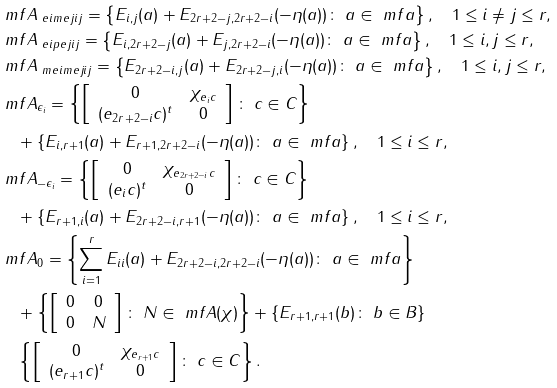Convert formula to latex. <formula><loc_0><loc_0><loc_500><loc_500>& \ m f A _ { \ e i m e j { i } { j } } = \left \{ E _ { i , j } ( a ) + E _ { 2 r + 2 - j , 2 r + 2 - i } ( - \eta ( a ) ) \colon \ a \in \ m f a \right \} , \quad 1 \leq i \neq j \leq r , \\ & \ m f A _ { \ e i p e j { i } { j } } = \left \{ E _ { i , 2 r + 2 - j } ( a ) + E _ { j , 2 r + 2 - i } ( - \eta ( a ) ) \colon \ a \in \ m f a \right \} , \quad 1 \leq i , j \leq r , \\ & \ m f A _ { \ m e i m e j { i } { j } } = \left \{ E _ { 2 r + 2 - i , j } ( a ) + E _ { 2 r + 2 - j , i } ( - \eta ( a ) ) \colon \ a \in \ m f a \right \} , \quad 1 \leq i , j \leq r , \\ & \ m f A _ { \epsilon _ { i } } = \left \{ \left [ \begin{array} { c c } 0 & \chi _ { e _ { i } c } \\ ( e _ { 2 r + 2 - i } c ) ^ { t } & 0 \end{array} \right ] \colon \ c \in C \right \} \\ & \quad + \left \{ E _ { i , r + 1 } ( a ) + E _ { r + 1 , 2 r + 2 - i } ( - \eta ( a ) ) \colon \ a \in \ m f a \right \} , \quad 1 \leq i \leq r , \\ & \ m f A _ { - \epsilon _ { i } } = \left \{ \left [ \begin{array} { c c } 0 & \chi _ { e _ { 2 r + 2 - i } c } \\ ( e _ { i } c ) ^ { t } & 0 \end{array} \right ] \colon \ c \in C \right \} \\ & \quad + \left \{ E _ { r + 1 , i } ( a ) + E _ { 2 r + 2 - i , r + 1 } ( - \eta ( a ) ) \colon \ a \in \ m f a \right \} , \quad 1 \leq i \leq r , \\ & \ m f A _ { 0 } = \left \{ \sum _ { i = 1 } ^ { r } E _ { i i } ( a ) + E _ { 2 r + 2 - i , 2 r + 2 - i } ( - \eta ( a ) ) \colon \ a \in \ m f a \right \} \\ & \quad + \left \{ \left [ \begin{array} { c c } 0 & 0 \\ 0 & N \end{array} \right ] \colon \ N \in \ m f A ( \chi ) \right \} + \left \{ E _ { r + 1 , r + 1 } ( b ) \colon \ b \in B \right \} \\ & \quad \left \{ \left [ \begin{array} { c c } 0 & \chi _ { e _ { r + 1 } c } \\ ( e _ { r + 1 } c ) ^ { t } & 0 \end{array} \right ] \colon \ c \in C \right \} .</formula> 